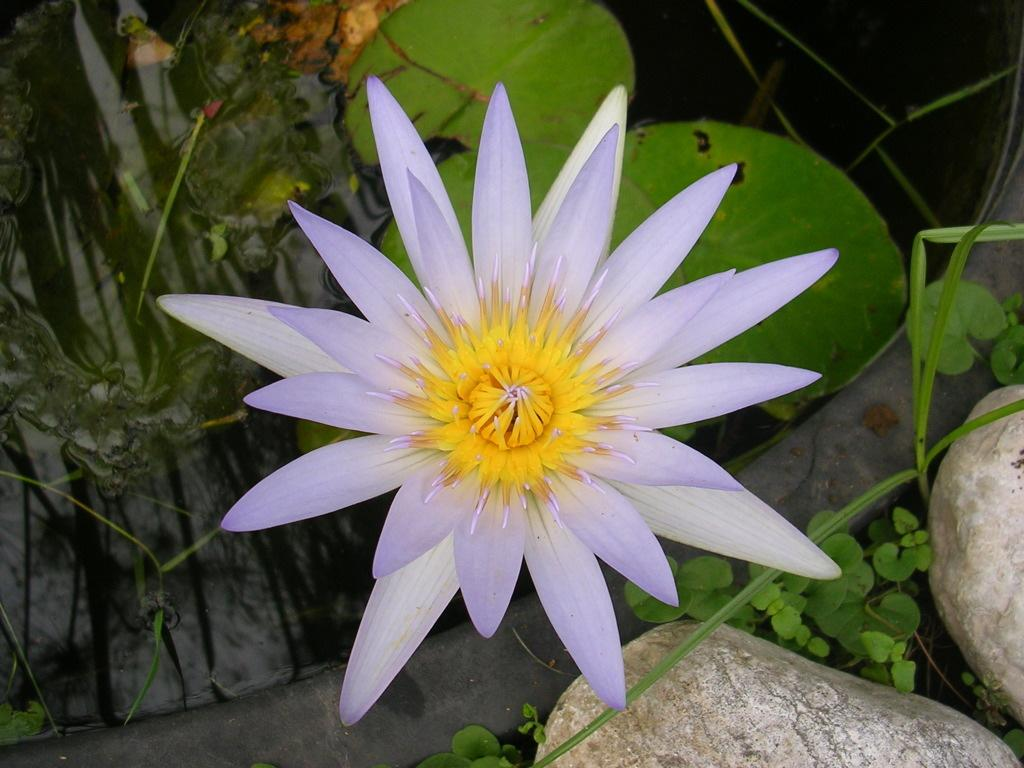What type of flower is in the image? There is a yellow and purple flower in the image. How would you describe the size of the flower's leaves? The flower has huge leaves. What other objects are near the flower in the image? There are two big stones beside the flower in the image. What type of vegetable is growing beside the flower in the image? There is no vegetable present in the image; it only features a yellow and purple flower and two big stones. 